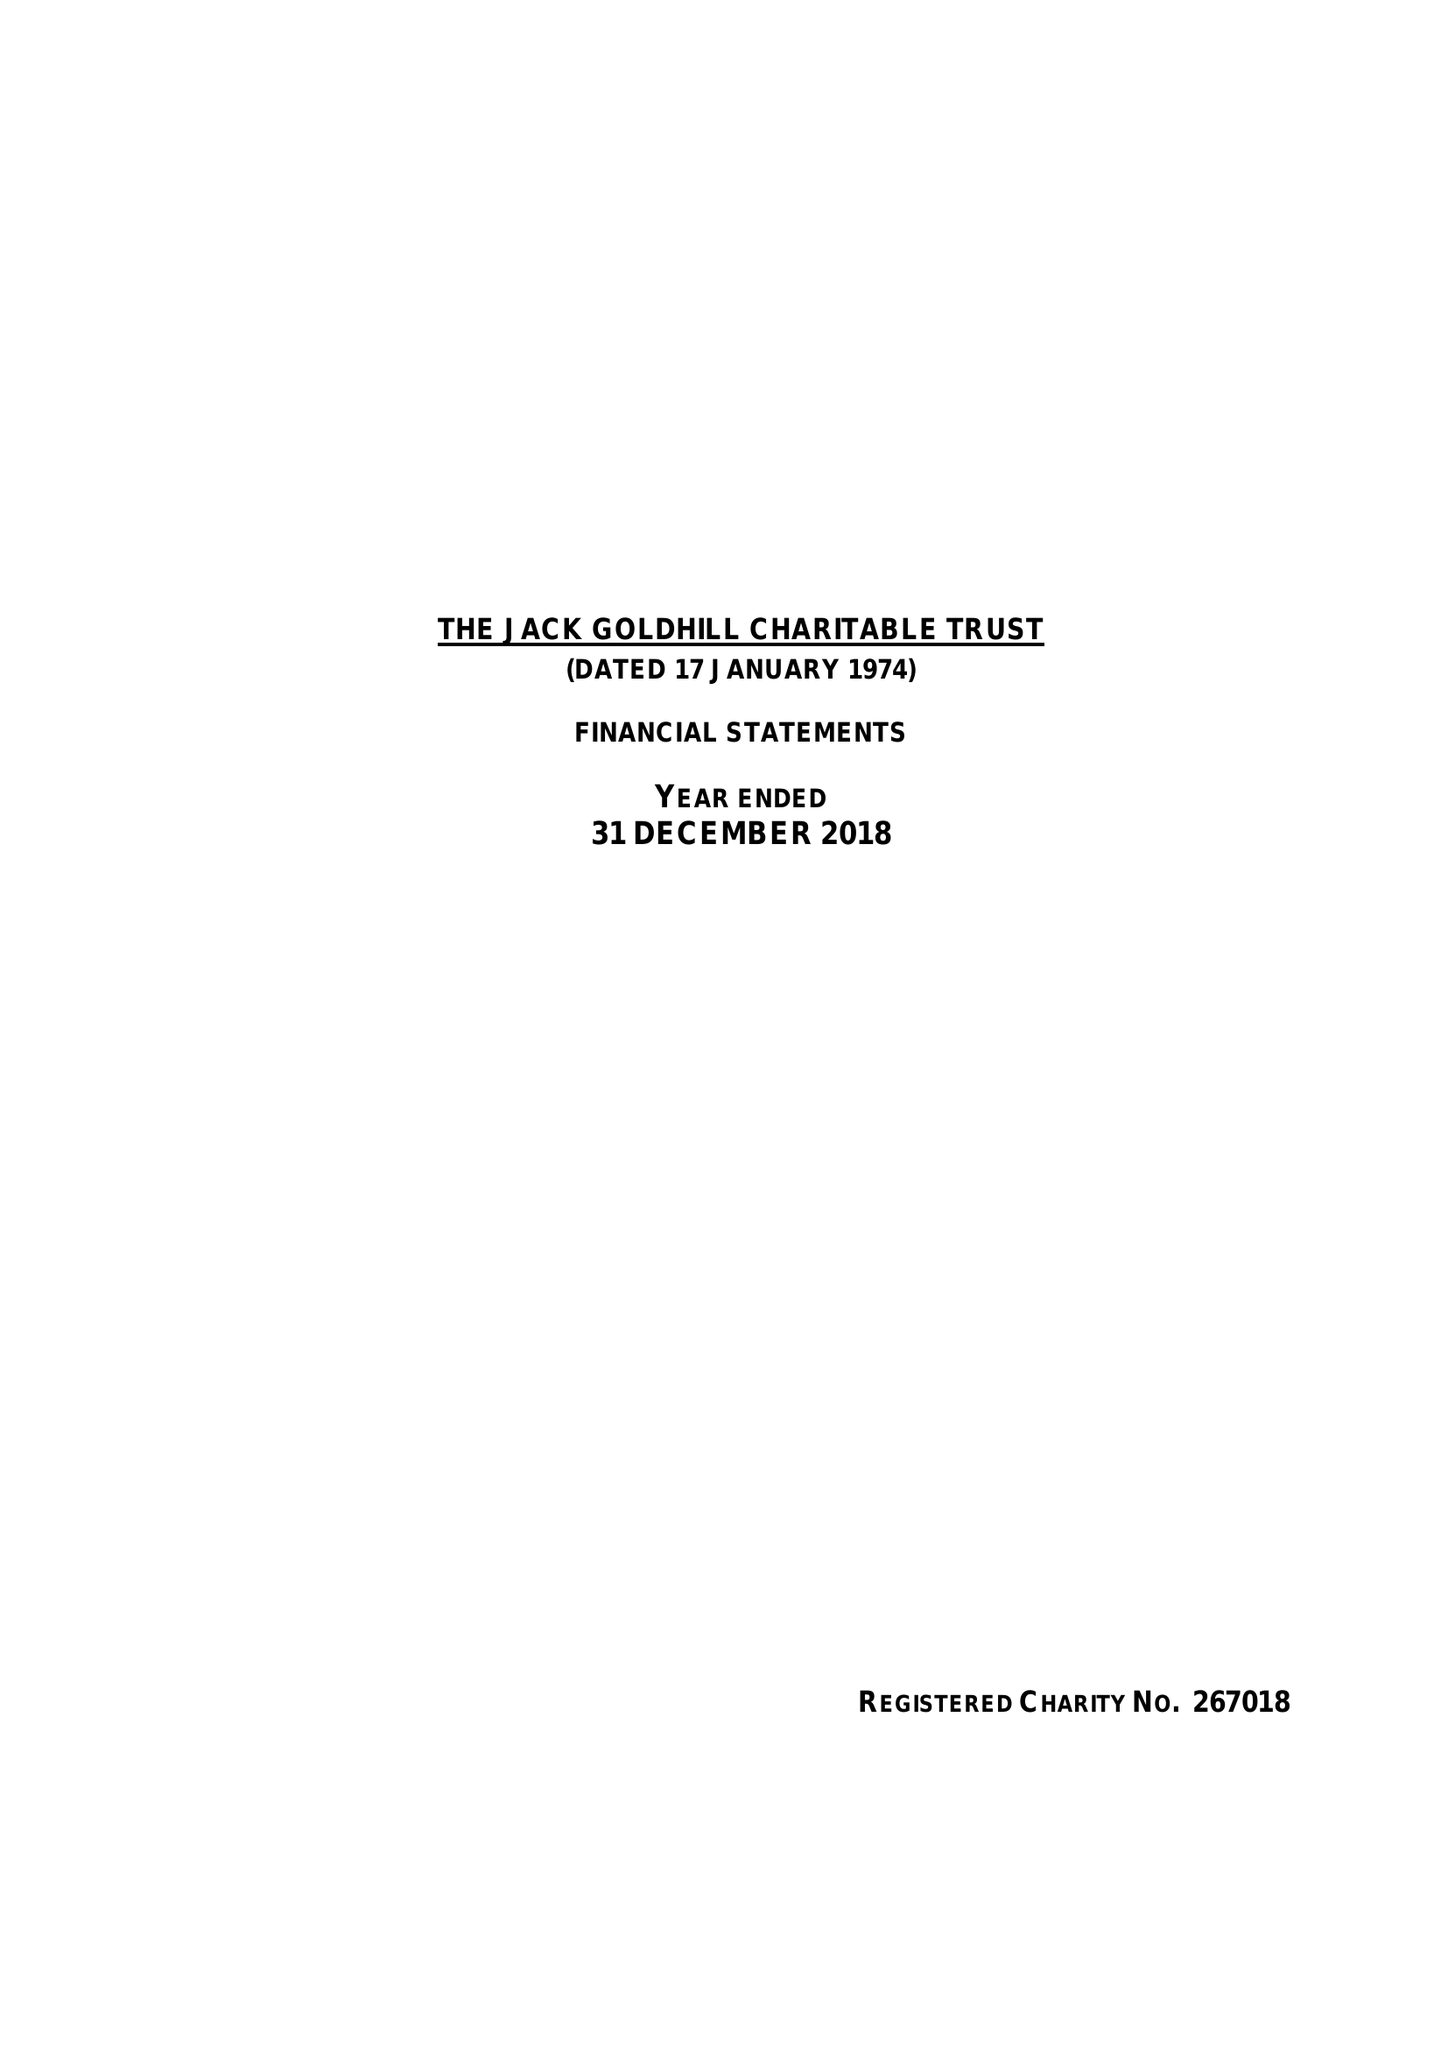What is the value for the charity_number?
Answer the question using a single word or phrase. 267018 